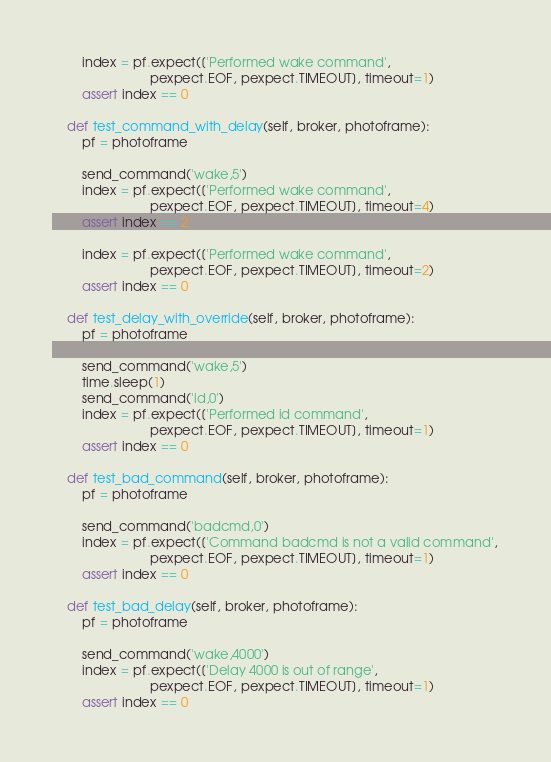<code> <loc_0><loc_0><loc_500><loc_500><_Python_>        index = pf.expect(['Performed wake command',
                           pexpect.EOF, pexpect.TIMEOUT], timeout=1)
        assert index == 0

    def test_command_with_delay(self, broker, photoframe):
        pf = photoframe

        send_command('wake,5')
        index = pf.expect(['Performed wake command',
                           pexpect.EOF, pexpect.TIMEOUT], timeout=4)
        assert index == 2

        index = pf.expect(['Performed wake command',
                           pexpect.EOF, pexpect.TIMEOUT], timeout=2)
        assert index == 0

    def test_delay_with_override(self, broker, photoframe):
        pf = photoframe

        send_command('wake,5')
        time.sleep(1)
        send_command('id,0')
        index = pf.expect(['Performed id command',
                           pexpect.EOF, pexpect.TIMEOUT], timeout=1)
        assert index == 0

    def test_bad_command(self, broker, photoframe):
        pf = photoframe

        send_command('badcmd,0')
        index = pf.expect(['Command badcmd is not a valid command',
                           pexpect.EOF, pexpect.TIMEOUT], timeout=1)
        assert index == 0

    def test_bad_delay(self, broker, photoframe):
        pf = photoframe

        send_command('wake,4000')
        index = pf.expect(['Delay 4000 is out of range',
                           pexpect.EOF, pexpect.TIMEOUT], timeout=1)
        assert index == 0
</code> 